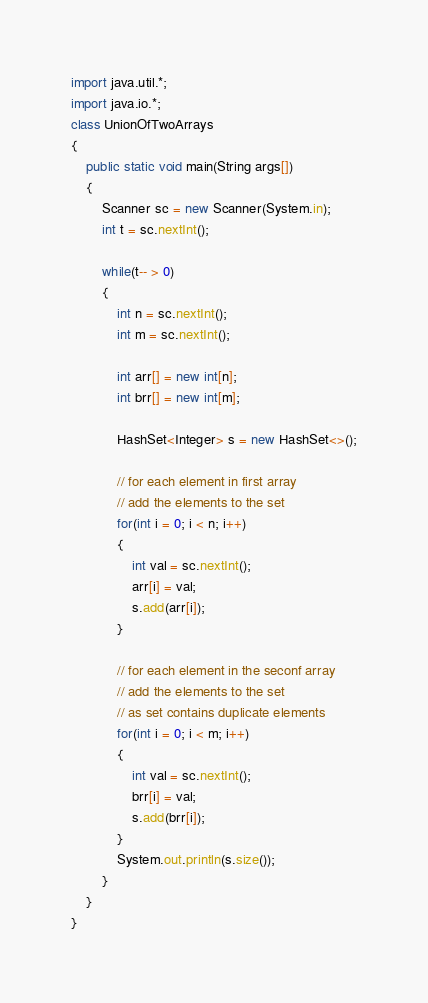<code> <loc_0><loc_0><loc_500><loc_500><_Java_>import java.util.*;
import java.io.*;
class UnionOfTwoArrays
{
    public static void main(String args[])
    {
        Scanner sc = new Scanner(System.in);
        int t = sc.nextInt();
        
        while(t-- > 0)
        {
            int n = sc.nextInt();
            int m = sc.nextInt();
            
            int arr[] = new int[n];
            int brr[] = new int[m];
            
            HashSet<Integer> s = new HashSet<>();
            
            // for each element in first array
            // add the elements to the set
            for(int i = 0; i < n; i++)
            {
                int val = sc.nextInt();
                arr[i] = val;
                s.add(arr[i]);
            }
            
            // for each element in the seconf array
            // add the elements to the set
            // as set contains duplicate elements
            for(int i = 0; i < m; i++)
            {
                int val = sc.nextInt();
                brr[i] = val;
                s.add(brr[i]);
            }
            System.out.println(s.size());
        }
    }
}</code> 